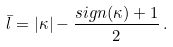<formula> <loc_0><loc_0><loc_500><loc_500>\bar { l } = | \kappa | - \frac { s i g n ( \kappa ) + 1 } { 2 } \, .</formula> 